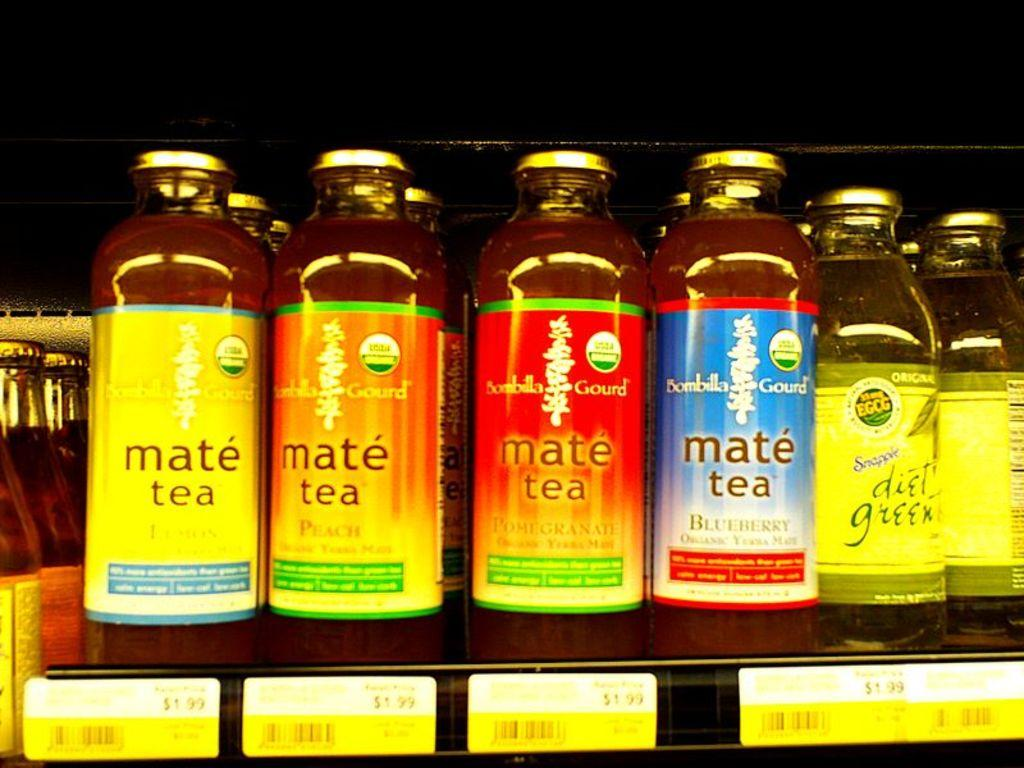<image>
Summarize the visual content of the image. bottles of different flavors of mate tea on a store shelf 